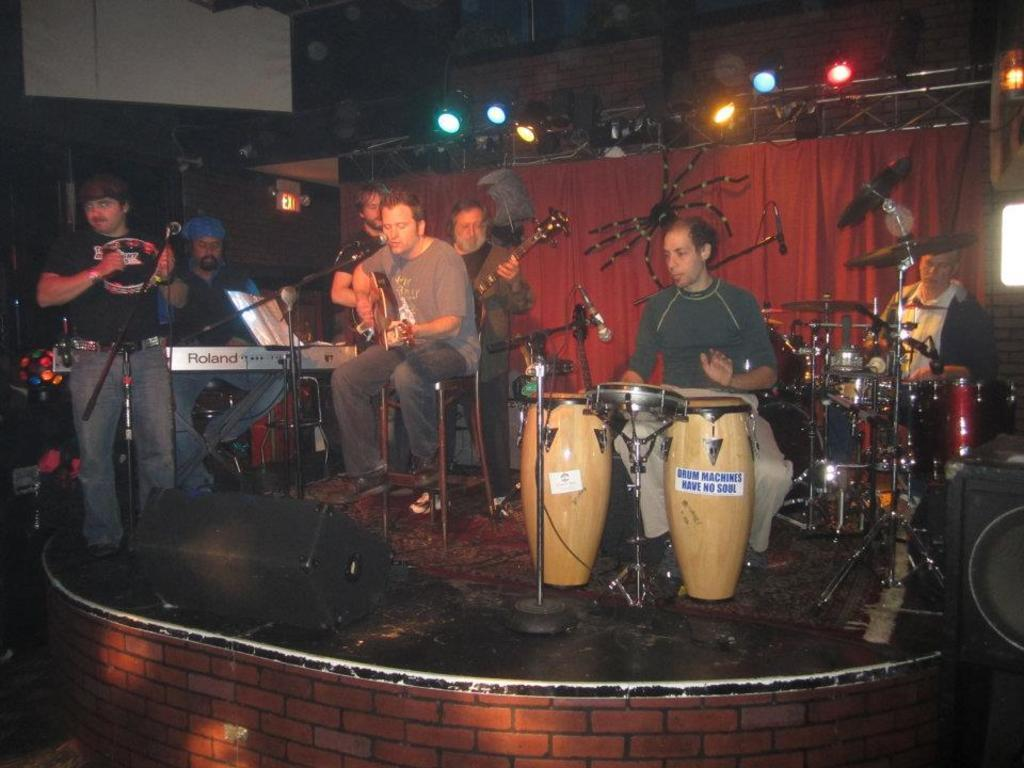Who or what can be seen in the image? There are people in the image. What are the people doing in the image? The people are playing musical instruments. Where are the people located in the image? The people are on a stage. What can be seen above the stage in the image? There are lights above the stage on the ceiling. What type of scarf is being used as a vessel by the people on the stage? There is no scarf or vessel present in the image; the people are playing musical instruments on a stage with lights above it. 